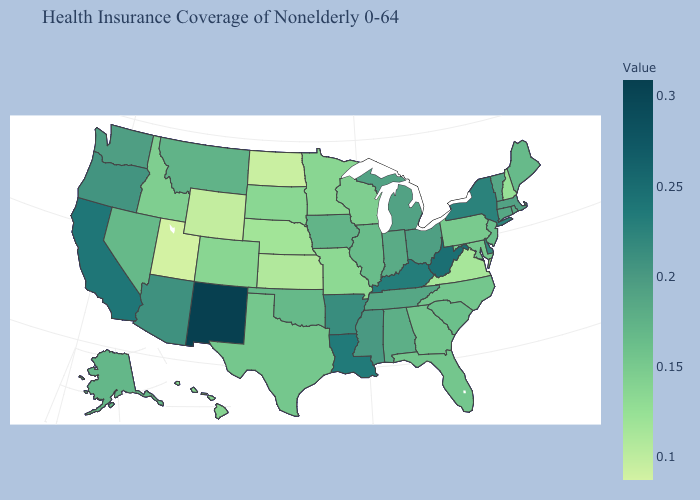Does Pennsylvania have the lowest value in the Northeast?
Answer briefly. No. Does Utah have the lowest value in the USA?
Give a very brief answer. Yes. Among the states that border Connecticut , does New York have the lowest value?
Concise answer only. No. 